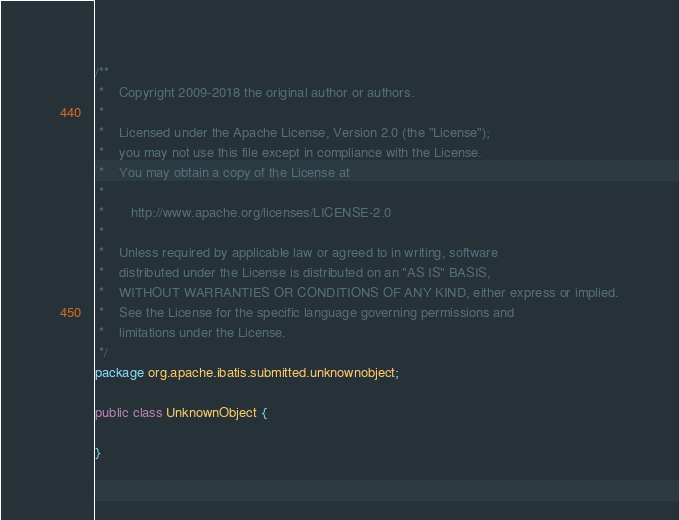<code> <loc_0><loc_0><loc_500><loc_500><_Java_>/**
 *    Copyright 2009-2018 the original author or authors.
 *
 *    Licensed under the Apache License, Version 2.0 (the "License");
 *    you may not use this file except in compliance with the License.
 *    You may obtain a copy of the License at
 *
 *       http://www.apache.org/licenses/LICENSE-2.0
 *
 *    Unless required by applicable law or agreed to in writing, software
 *    distributed under the License is distributed on an "AS IS" BASIS,
 *    WITHOUT WARRANTIES OR CONDITIONS OF ANY KIND, either express or implied.
 *    See the License for the specific language governing permissions and
 *    limitations under the License.
 */
package org.apache.ibatis.submitted.unknownobject;

public class UnknownObject {

}
</code> 